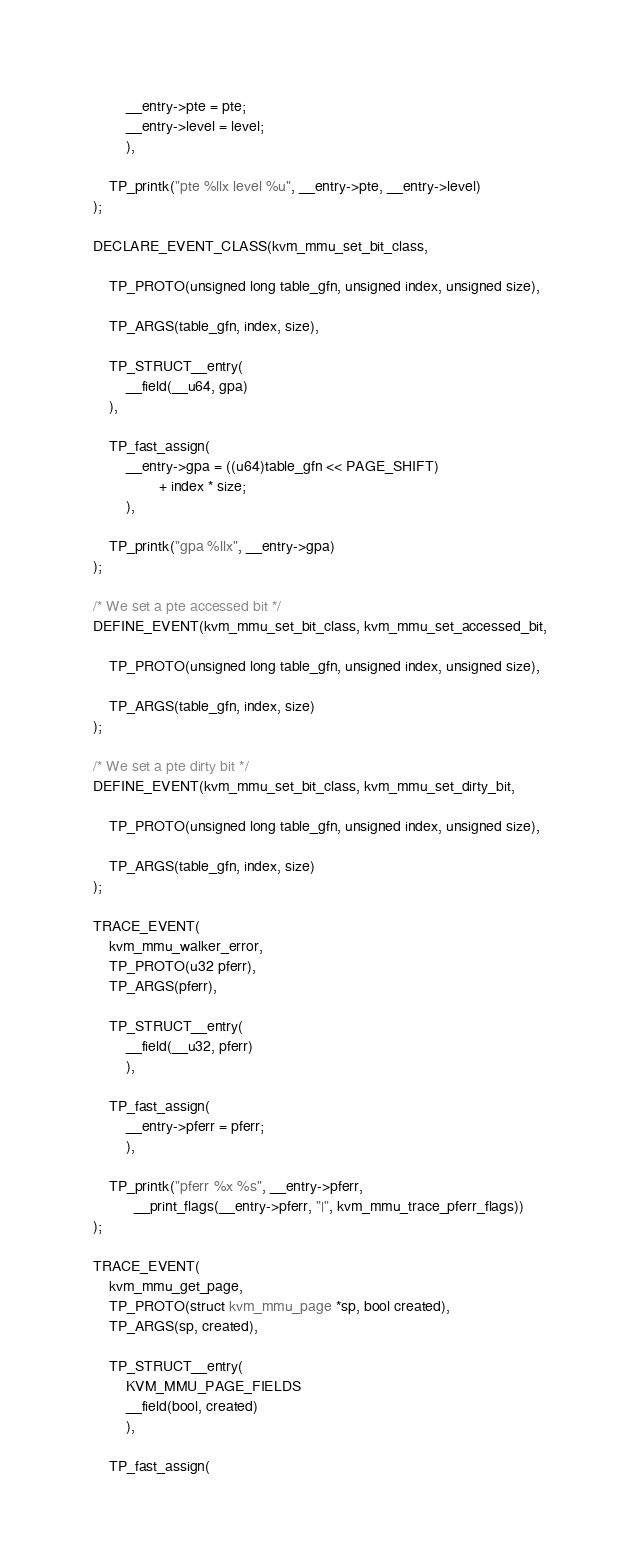<code> <loc_0><loc_0><loc_500><loc_500><_C_>		__entry->pte = pte;
		__entry->level = level;
		),

	TP_printk("pte %llx level %u", __entry->pte, __entry->level)
);

DECLARE_EVENT_CLASS(kvm_mmu_set_bit_class,

	TP_PROTO(unsigned long table_gfn, unsigned index, unsigned size),

	TP_ARGS(table_gfn, index, size),

	TP_STRUCT__entry(
		__field(__u64, gpa)
	),

	TP_fast_assign(
		__entry->gpa = ((u64)table_gfn << PAGE_SHIFT)
				+ index * size;
		),

	TP_printk("gpa %llx", __entry->gpa)
);

/* We set a pte accessed bit */
DEFINE_EVENT(kvm_mmu_set_bit_class, kvm_mmu_set_accessed_bit,

	TP_PROTO(unsigned long table_gfn, unsigned index, unsigned size),

	TP_ARGS(table_gfn, index, size)
);

/* We set a pte dirty bit */
DEFINE_EVENT(kvm_mmu_set_bit_class, kvm_mmu_set_dirty_bit,

	TP_PROTO(unsigned long table_gfn, unsigned index, unsigned size),

	TP_ARGS(table_gfn, index, size)
);

TRACE_EVENT(
	kvm_mmu_walker_error,
	TP_PROTO(u32 pferr),
	TP_ARGS(pferr),

	TP_STRUCT__entry(
		__field(__u32, pferr)
		),

	TP_fast_assign(
		__entry->pferr = pferr;
		),

	TP_printk("pferr %x %s", __entry->pferr,
		  __print_flags(__entry->pferr, "|", kvm_mmu_trace_pferr_flags))
);

TRACE_EVENT(
	kvm_mmu_get_page,
	TP_PROTO(struct kvm_mmu_page *sp, bool created),
	TP_ARGS(sp, created),

	TP_STRUCT__entry(
		KVM_MMU_PAGE_FIELDS
		__field(bool, created)
		),

	TP_fast_assign(</code> 